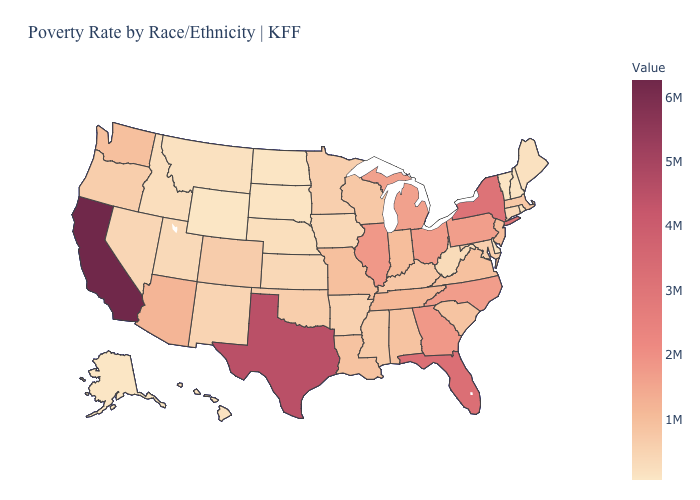Is the legend a continuous bar?
Write a very short answer. Yes. Among the states that border Indiana , which have the lowest value?
Concise answer only. Kentucky. Does Delaware have the lowest value in the South?
Keep it brief. Yes. Which states have the lowest value in the USA?
Write a very short answer. Wyoming. Which states hav the highest value in the Northeast?
Write a very short answer. New York. Does Arizona have the lowest value in the West?
Give a very brief answer. No. Does the map have missing data?
Short answer required. No. Does Wyoming have the lowest value in the USA?
Write a very short answer. Yes. 